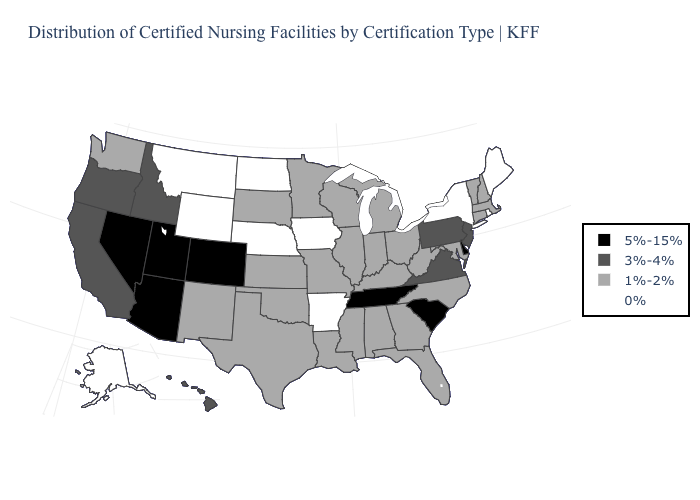What is the value of Vermont?
Answer briefly. 1%-2%. What is the value of Maine?
Write a very short answer. 0%. Name the states that have a value in the range 5%-15%?
Quick response, please. Arizona, Colorado, Delaware, Nevada, South Carolina, Tennessee, Utah. What is the highest value in states that border South Dakota?
Give a very brief answer. 1%-2%. Name the states that have a value in the range 5%-15%?
Concise answer only. Arizona, Colorado, Delaware, Nevada, South Carolina, Tennessee, Utah. Which states hav the highest value in the West?
Short answer required. Arizona, Colorado, Nevada, Utah. What is the value of West Virginia?
Write a very short answer. 1%-2%. Among the states that border Alabama , does Tennessee have the highest value?
Write a very short answer. Yes. Name the states that have a value in the range 3%-4%?
Write a very short answer. California, Hawaii, Idaho, New Jersey, Oregon, Pennsylvania, Virginia. What is the value of North Carolina?
Write a very short answer. 1%-2%. Name the states that have a value in the range 1%-2%?
Keep it brief. Alabama, Connecticut, Florida, Georgia, Illinois, Indiana, Kansas, Kentucky, Louisiana, Maryland, Massachusetts, Michigan, Minnesota, Mississippi, Missouri, New Hampshire, New Mexico, North Carolina, Ohio, Oklahoma, South Dakota, Texas, Vermont, Washington, West Virginia, Wisconsin. Does California have a higher value than Kansas?
Write a very short answer. Yes. Name the states that have a value in the range 3%-4%?
Keep it brief. California, Hawaii, Idaho, New Jersey, Oregon, Pennsylvania, Virginia. What is the value of Louisiana?
Concise answer only. 1%-2%. What is the value of Idaho?
Quick response, please. 3%-4%. 